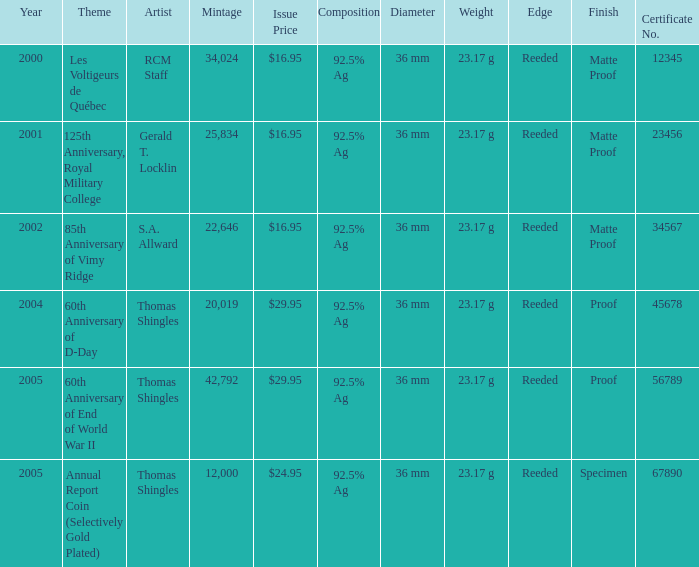What was the total mintage for years after 2002 that had a 85th Anniversary of Vimy Ridge theme? 0.0. Write the full table. {'header': ['Year', 'Theme', 'Artist', 'Mintage', 'Issue Price', 'Composition', 'Diameter', 'Weight', 'Edge', 'Finish', 'Certificate No.'], 'rows': [['2000', 'Les Voltigeurs de Québec', 'RCM Staff', '34,024', '$16.95', '92.5% Ag', '36 mm', '23.17 g', 'Reeded', 'Matte Proof', '12345'], ['2001', '125th Anniversary, Royal Military College', 'Gerald T. Locklin', '25,834', '$16.95', '92.5% Ag', '36 mm', '23.17 g', 'Reeded', 'Matte Proof', '23456'], ['2002', '85th Anniversary of Vimy Ridge', 'S.A. Allward', '22,646', '$16.95', '92.5% Ag', '36 mm', '23.17 g', 'Reeded', 'Matte Proof', '34567'], ['2004', '60th Anniversary of D-Day', 'Thomas Shingles', '20,019', '$29.95', '92.5% Ag', '36 mm', '23.17 g', 'Reeded', 'Proof', '45678'], ['2005', '60th Anniversary of End of World War II', 'Thomas Shingles', '42,792', '$29.95', '92.5% Ag', '36 mm', '23.17 g', 'Reeded', 'Proof', '56789'], ['2005', 'Annual Report Coin (Selectively Gold Plated)', 'Thomas Shingles', '12,000', '$24.95', '92.5% Ag', '36 mm', '23.17 g', 'Reeded', 'Specimen', '67890']]} 